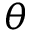Convert formula to latex. <formula><loc_0><loc_0><loc_500><loc_500>\theta</formula> 